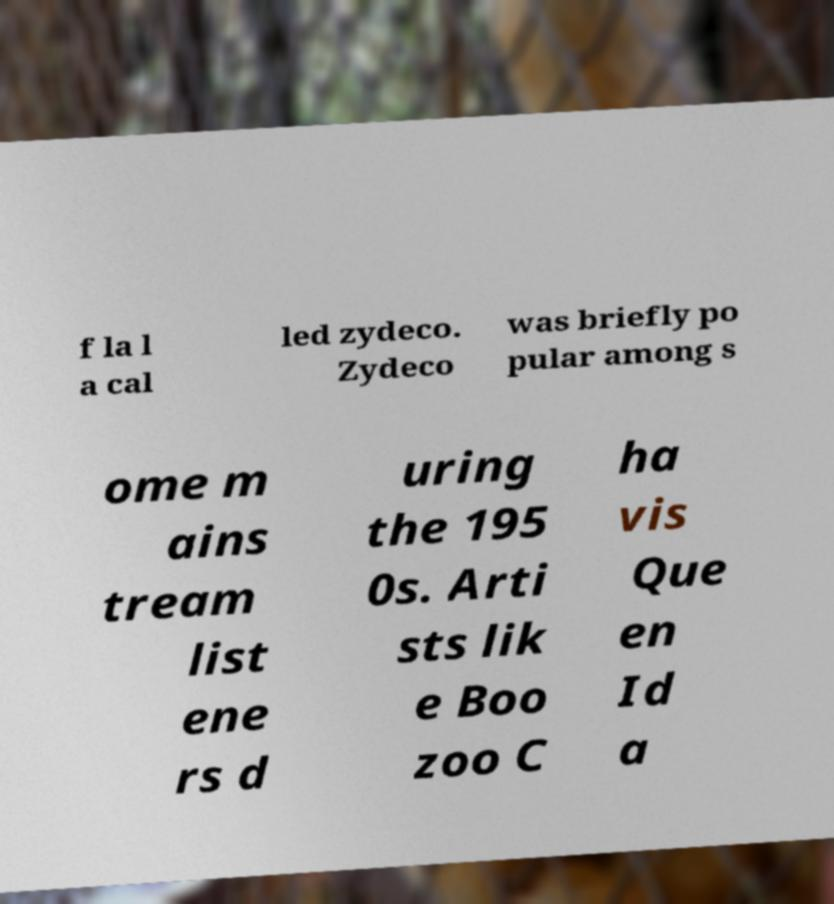I need the written content from this picture converted into text. Can you do that? f la l a cal led zydeco. Zydeco was briefly po pular among s ome m ains tream list ene rs d uring the 195 0s. Arti sts lik e Boo zoo C ha vis Que en Id a 